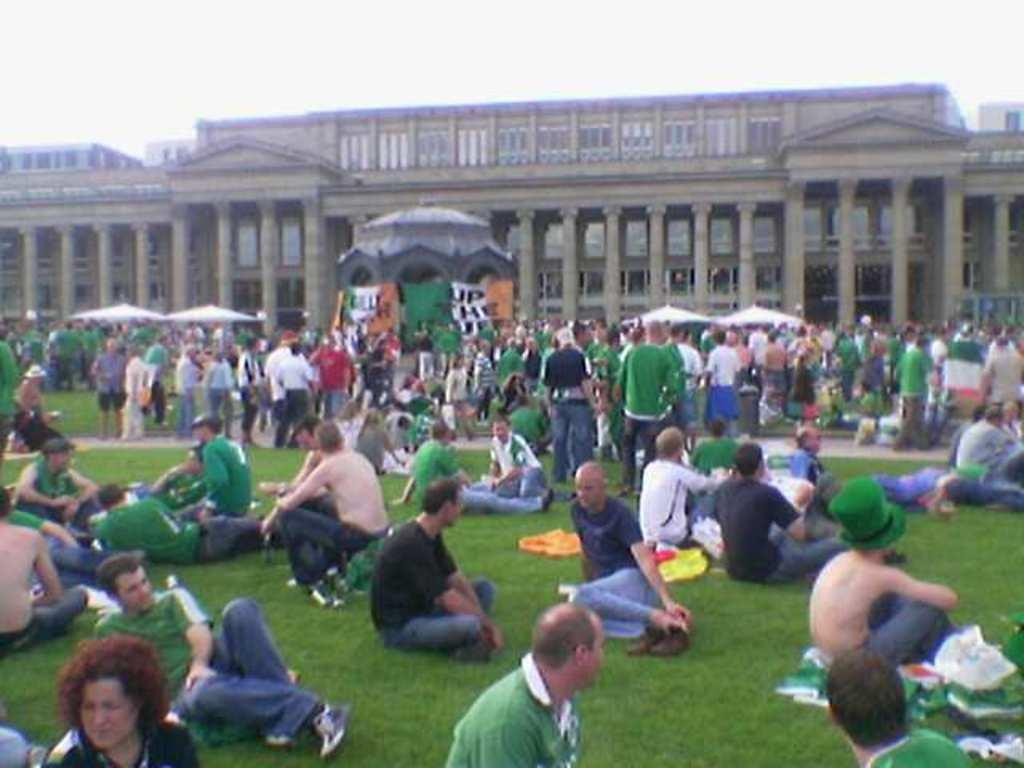How many people are present in the image? There are many people in the image. What are some of the people in the image doing? Some people are sitting, while others are standing. What can be seen in the background of the image? There is a building with pillars in the background. What is visible in the sky in the image? The sky is visible in the image. What type of temporary shelter is present in the image? There are tents in the image. What is the taste of the brick in the image? There is no brick present in the image, so it is not possible to determine its taste. 